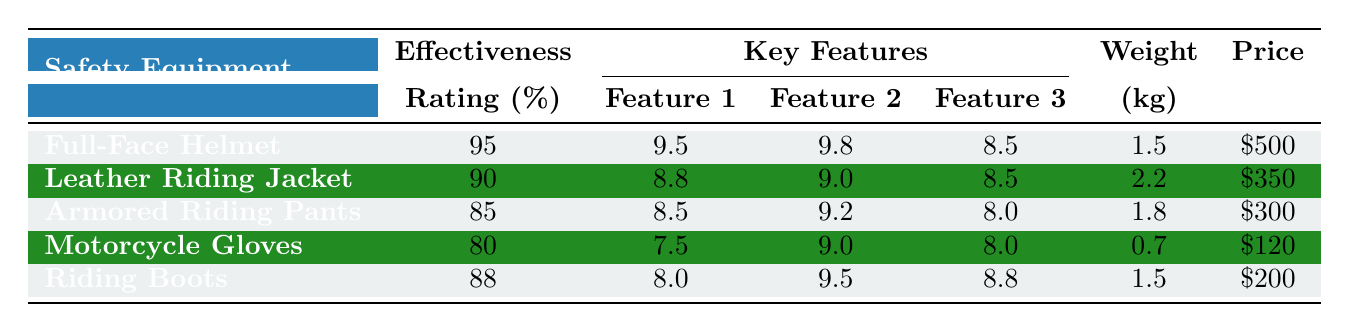What is the effectiveness rating of the Full-Face Helmet? The table provides a column for effectiveness rating, specifically for the Full-Face Helmet, which shows it as 95%.
Answer: 95% Which safety equipment has the highest impact absorption rating? By looking at the impact absorption ratings in the table, the Full-Face Helmet has the highest rating of 9.5.
Answer: Full-Face Helmet What is the total price of a Leather Riding Jacket and Motorcycle Gloves? The price of the Leather Riding Jacket is $350 and the Motorcycle Gloves is $120. Adding these together gives $350 + $120 = $470.
Answer: $470 True or False: Riding Boots are heavier than Motorcycle Gloves. Comparing the weights, Riding Boots are 1.5 kg and Motorcycle Gloves are 0.7 kg; therefore, Riding Boots are indeed heavier.
Answer: True What is the average effectiveness rating of all safety equipment listed? The effectiveness ratings are 95, 90, 85, 80, and 88. Summing these gives 438. Dividing by the number of items (5) gives an average of 438 / 5 = 87.6.
Answer: 87.6 